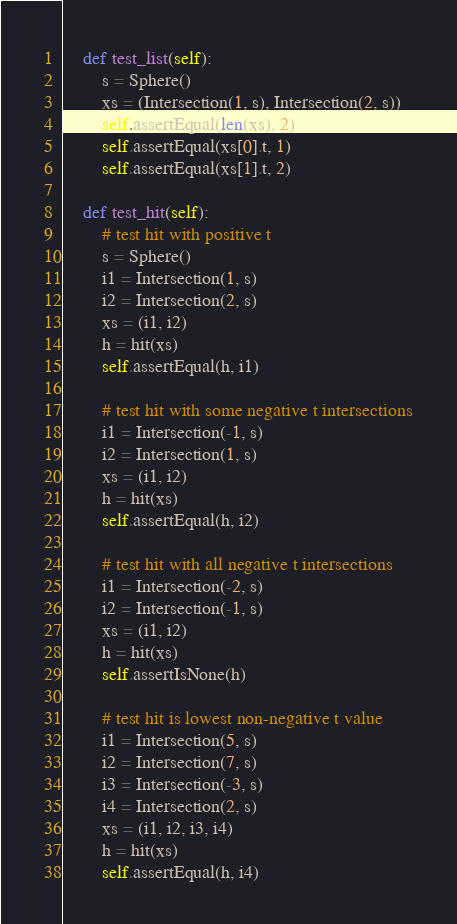<code> <loc_0><loc_0><loc_500><loc_500><_Python_>    def test_list(self):
        s = Sphere()
        xs = (Intersection(1, s), Intersection(2, s))
        self.assertEqual(len(xs), 2)
        self.assertEqual(xs[0].t, 1)
        self.assertEqual(xs[1].t, 2)

    def test_hit(self):
        # test hit with positive t
        s = Sphere()
        i1 = Intersection(1, s)
        i2 = Intersection(2, s)
        xs = (i1, i2)
        h = hit(xs)
        self.assertEqual(h, i1)

        # test hit with some negative t intersections
        i1 = Intersection(-1, s)
        i2 = Intersection(1, s)
        xs = (i1, i2)
        h = hit(xs)
        self.assertEqual(h, i2)

        # test hit with all negative t intersections
        i1 = Intersection(-2, s)
        i2 = Intersection(-1, s)
        xs = (i1, i2)
        h = hit(xs)
        self.assertIsNone(h)

        # test hit is lowest non-negative t value
        i1 = Intersection(5, s)
        i2 = Intersection(7, s)
        i3 = Intersection(-3, s)
        i4 = Intersection(2, s)
        xs = (i1, i2, i3, i4)
        h = hit(xs)
        self.assertEqual(h, i4)

</code> 